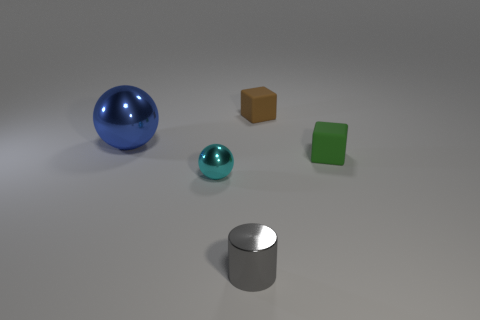Add 5 small metallic cylinders. How many objects exist? 10 Subtract all balls. How many objects are left? 3 Subtract all blue shiny things. Subtract all blue things. How many objects are left? 3 Add 3 matte blocks. How many matte blocks are left? 5 Add 3 big red spheres. How many big red spheres exist? 3 Subtract 0 red balls. How many objects are left? 5 Subtract all red blocks. Subtract all blue balls. How many blocks are left? 2 